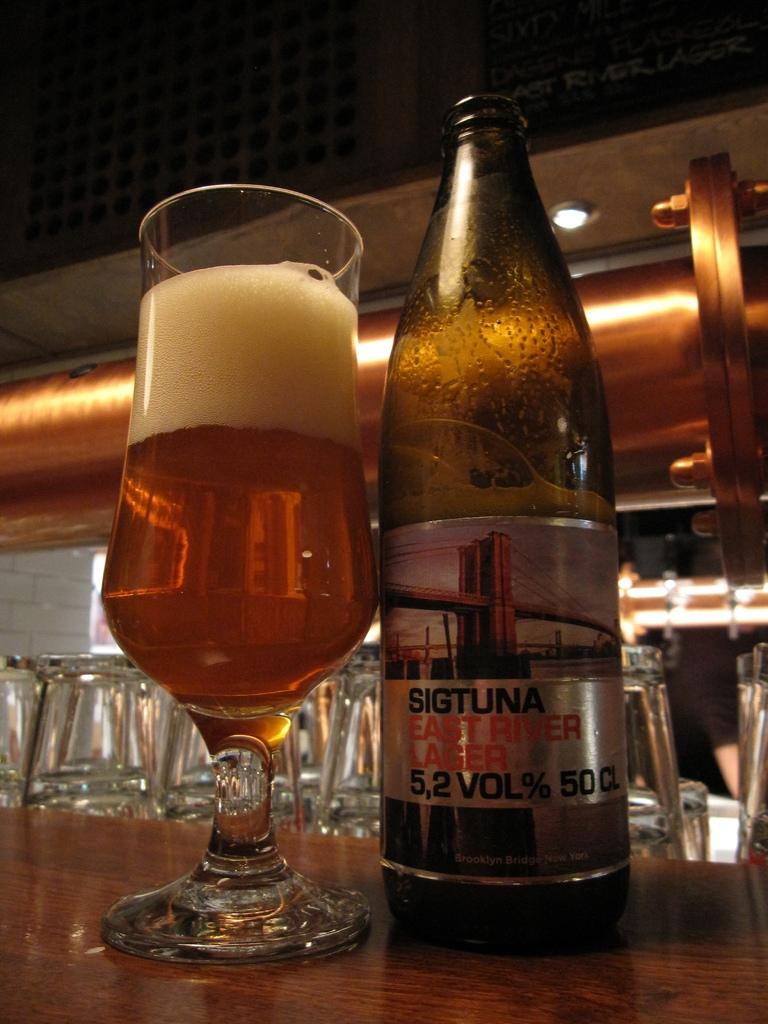Provide a one-sentence caption for the provided image. A bottle of Sigtuna East River Lager sits next to a glass of beer on the bar. 